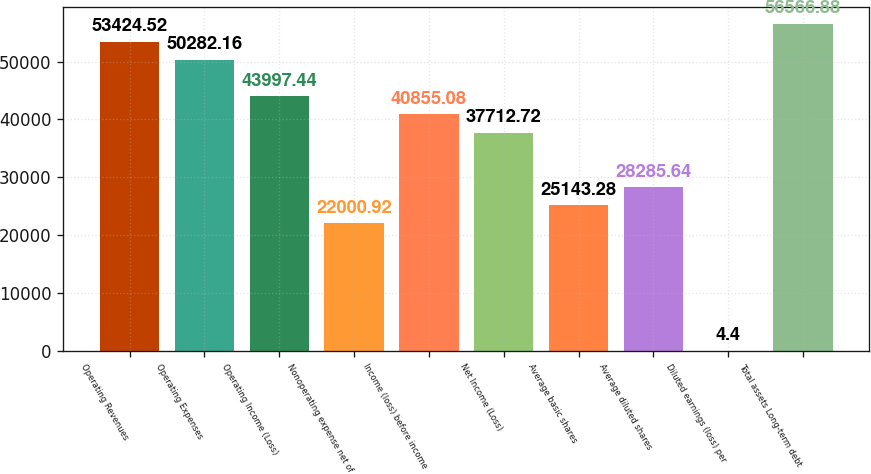Convert chart. <chart><loc_0><loc_0><loc_500><loc_500><bar_chart><fcel>Operating Revenues<fcel>Operating Expenses<fcel>Operating Income (Loss)<fcel>Nonoperating expense net of<fcel>Income (loss) before income<fcel>Net Income (Loss)<fcel>Average basic shares<fcel>Average diluted shares<fcel>Diluted earnings (loss) per<fcel>Total assets Long-term debt<nl><fcel>53424.5<fcel>50282.2<fcel>43997.4<fcel>22000.9<fcel>40855.1<fcel>37712.7<fcel>25143.3<fcel>28285.6<fcel>4.4<fcel>56566.9<nl></chart> 